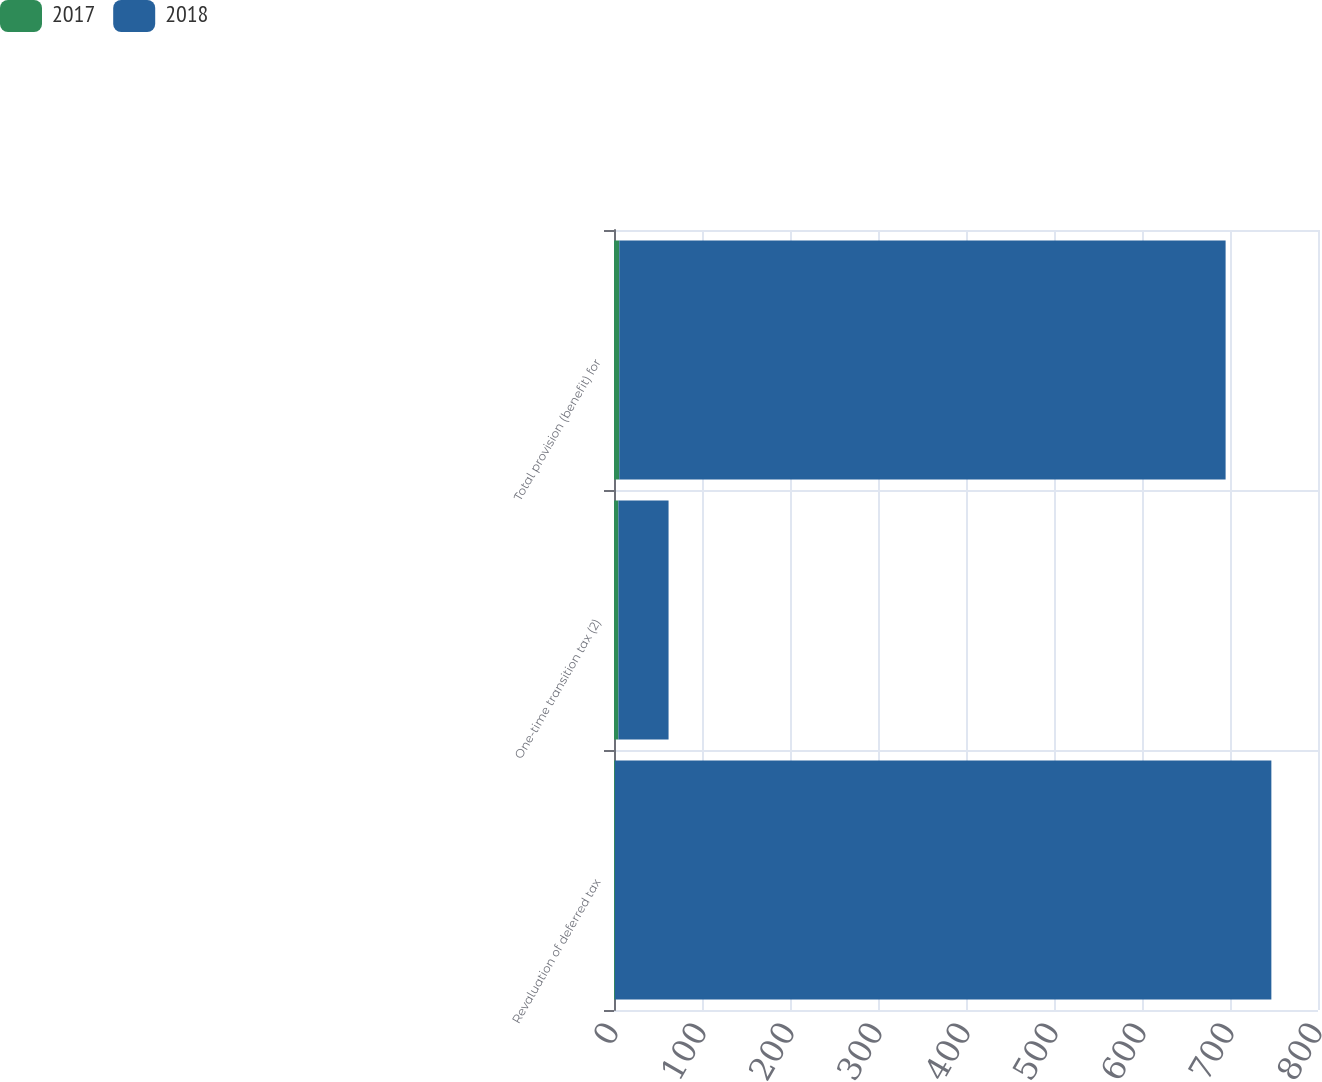Convert chart. <chart><loc_0><loc_0><loc_500><loc_500><stacked_bar_chart><ecel><fcel>Revaluation of deferred tax<fcel>One-time transition tax (2)<fcel>Total provision (benefit) for<nl><fcel>2017<fcel>1<fcel>5<fcel>6<nl><fcel>2018<fcel>746<fcel>57<fcel>689<nl></chart> 